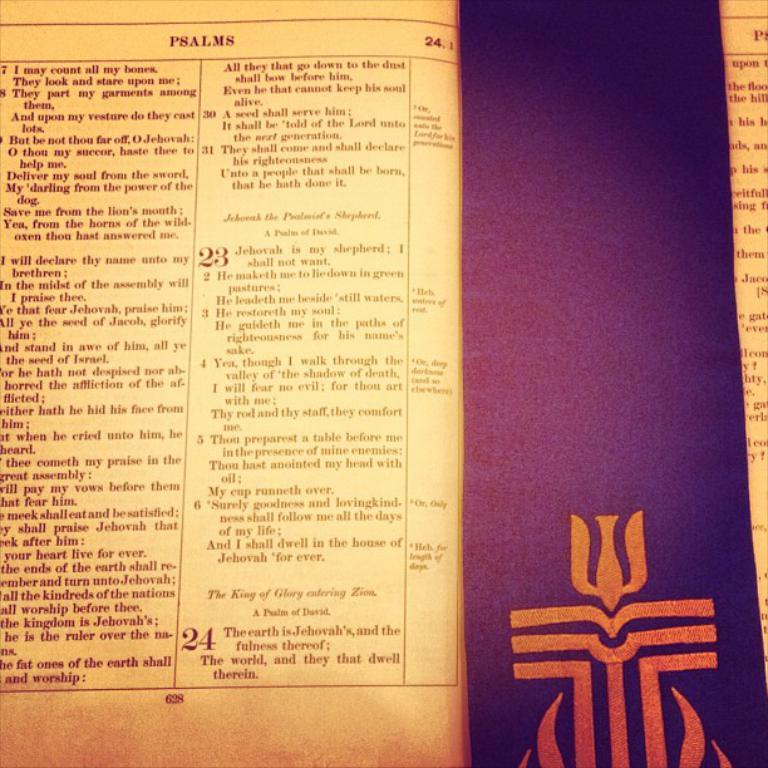<image>
Describe the image concisely. a page in a book with a religious touch, the top of the page reads PSALMS which describes what the page says below it. 